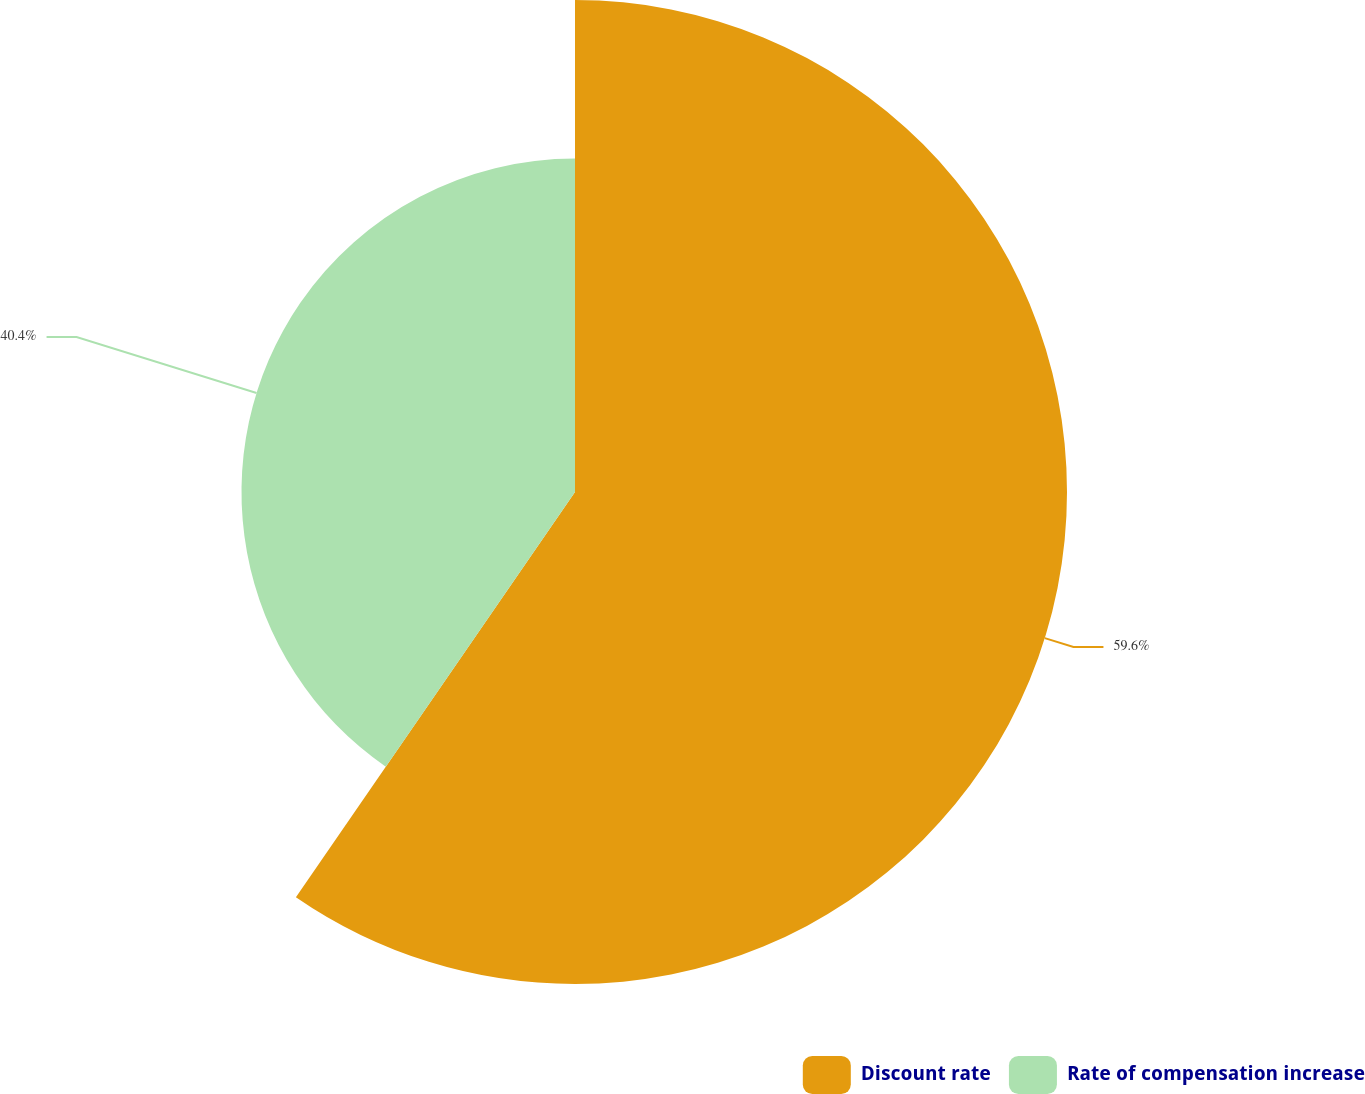<chart> <loc_0><loc_0><loc_500><loc_500><pie_chart><fcel>Discount rate<fcel>Rate of compensation increase<nl><fcel>59.6%<fcel>40.4%<nl></chart> 